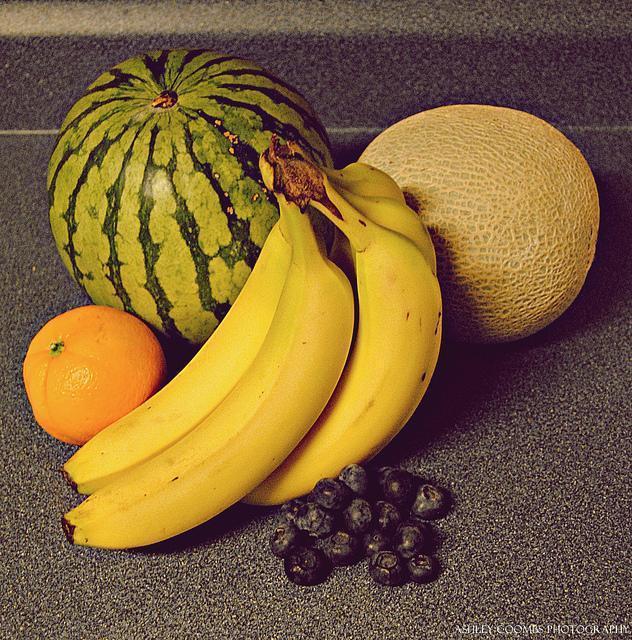How many of these fruits have to be cut before being eaten?
Give a very brief answer. 2. How many oranges are there?
Give a very brief answer. 1. How many types of fruits are there?
Give a very brief answer. 5. How many bananas are on the counter?
Give a very brief answer. 5. How many people have black shirts on?
Give a very brief answer. 0. 